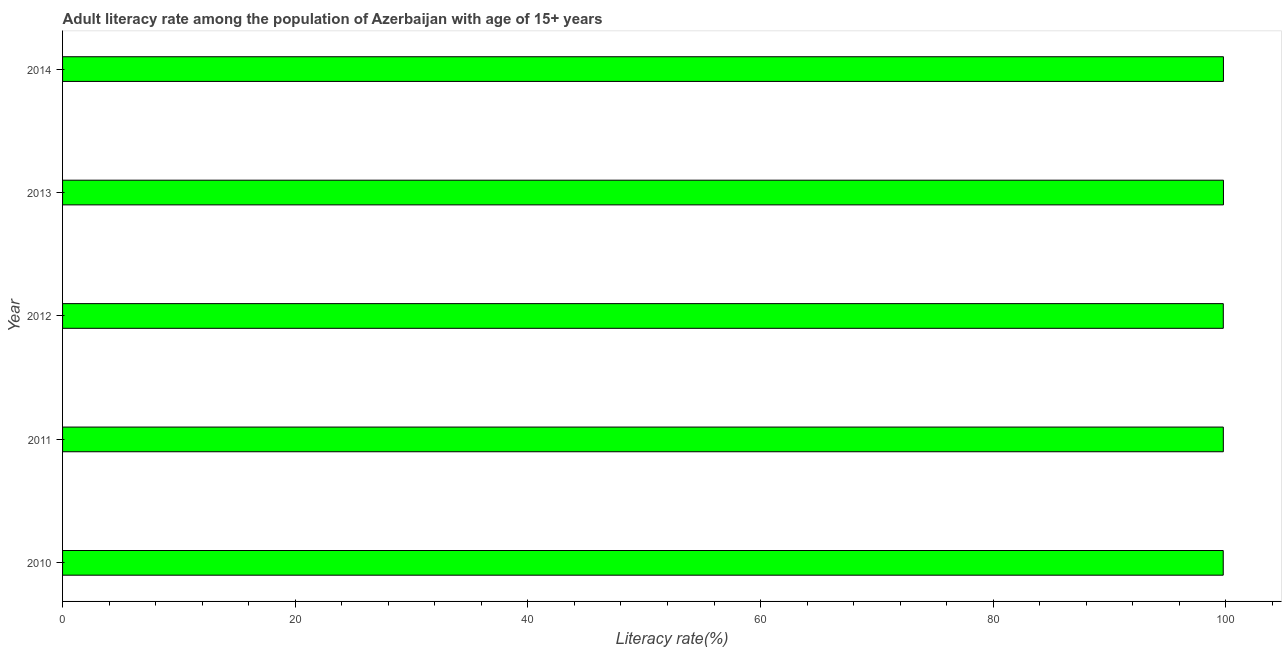What is the title of the graph?
Ensure brevity in your answer.  Adult literacy rate among the population of Azerbaijan with age of 15+ years. What is the label or title of the X-axis?
Make the answer very short. Literacy rate(%). What is the adult literacy rate in 2012?
Keep it short and to the point. 99.78. Across all years, what is the maximum adult literacy rate?
Your response must be concise. 99.79. Across all years, what is the minimum adult literacy rate?
Make the answer very short. 99.77. In which year was the adult literacy rate minimum?
Offer a very short reply. 2010. What is the sum of the adult literacy rate?
Make the answer very short. 498.9. What is the difference between the adult literacy rate in 2011 and 2012?
Provide a succinct answer. 0. What is the average adult literacy rate per year?
Offer a very short reply. 99.78. What is the median adult literacy rate?
Offer a terse response. 99.78. Do a majority of the years between 2010 and 2013 (inclusive) have adult literacy rate greater than 56 %?
Make the answer very short. Yes. Is the adult literacy rate in 2011 less than that in 2012?
Provide a short and direct response. No. Is the difference between the adult literacy rate in 2011 and 2012 greater than the difference between any two years?
Keep it short and to the point. No. What is the difference between the highest and the second highest adult literacy rate?
Your response must be concise. 0. What is the difference between the highest and the lowest adult literacy rate?
Your answer should be very brief. 0.02. In how many years, is the adult literacy rate greater than the average adult literacy rate taken over all years?
Keep it short and to the point. 2. What is the Literacy rate(%) in 2010?
Give a very brief answer. 99.77. What is the Literacy rate(%) in 2011?
Provide a short and direct response. 99.78. What is the Literacy rate(%) in 2012?
Offer a terse response. 99.78. What is the Literacy rate(%) of 2013?
Your answer should be very brief. 99.79. What is the Literacy rate(%) of 2014?
Give a very brief answer. 99.79. What is the difference between the Literacy rate(%) in 2010 and 2011?
Make the answer very short. -0.01. What is the difference between the Literacy rate(%) in 2010 and 2012?
Offer a terse response. -0. What is the difference between the Literacy rate(%) in 2010 and 2013?
Your response must be concise. -0.02. What is the difference between the Literacy rate(%) in 2010 and 2014?
Your response must be concise. -0.02. What is the difference between the Literacy rate(%) in 2011 and 2012?
Offer a terse response. 0. What is the difference between the Literacy rate(%) in 2011 and 2013?
Give a very brief answer. -0.01. What is the difference between the Literacy rate(%) in 2011 and 2014?
Provide a succinct answer. -0.01. What is the difference between the Literacy rate(%) in 2012 and 2013?
Provide a succinct answer. -0.01. What is the difference between the Literacy rate(%) in 2012 and 2014?
Ensure brevity in your answer.  -0.01. What is the difference between the Literacy rate(%) in 2013 and 2014?
Your answer should be compact. 0. What is the ratio of the Literacy rate(%) in 2010 to that in 2011?
Give a very brief answer. 1. What is the ratio of the Literacy rate(%) in 2010 to that in 2012?
Your response must be concise. 1. What is the ratio of the Literacy rate(%) in 2010 to that in 2014?
Give a very brief answer. 1. What is the ratio of the Literacy rate(%) in 2011 to that in 2013?
Offer a terse response. 1. 